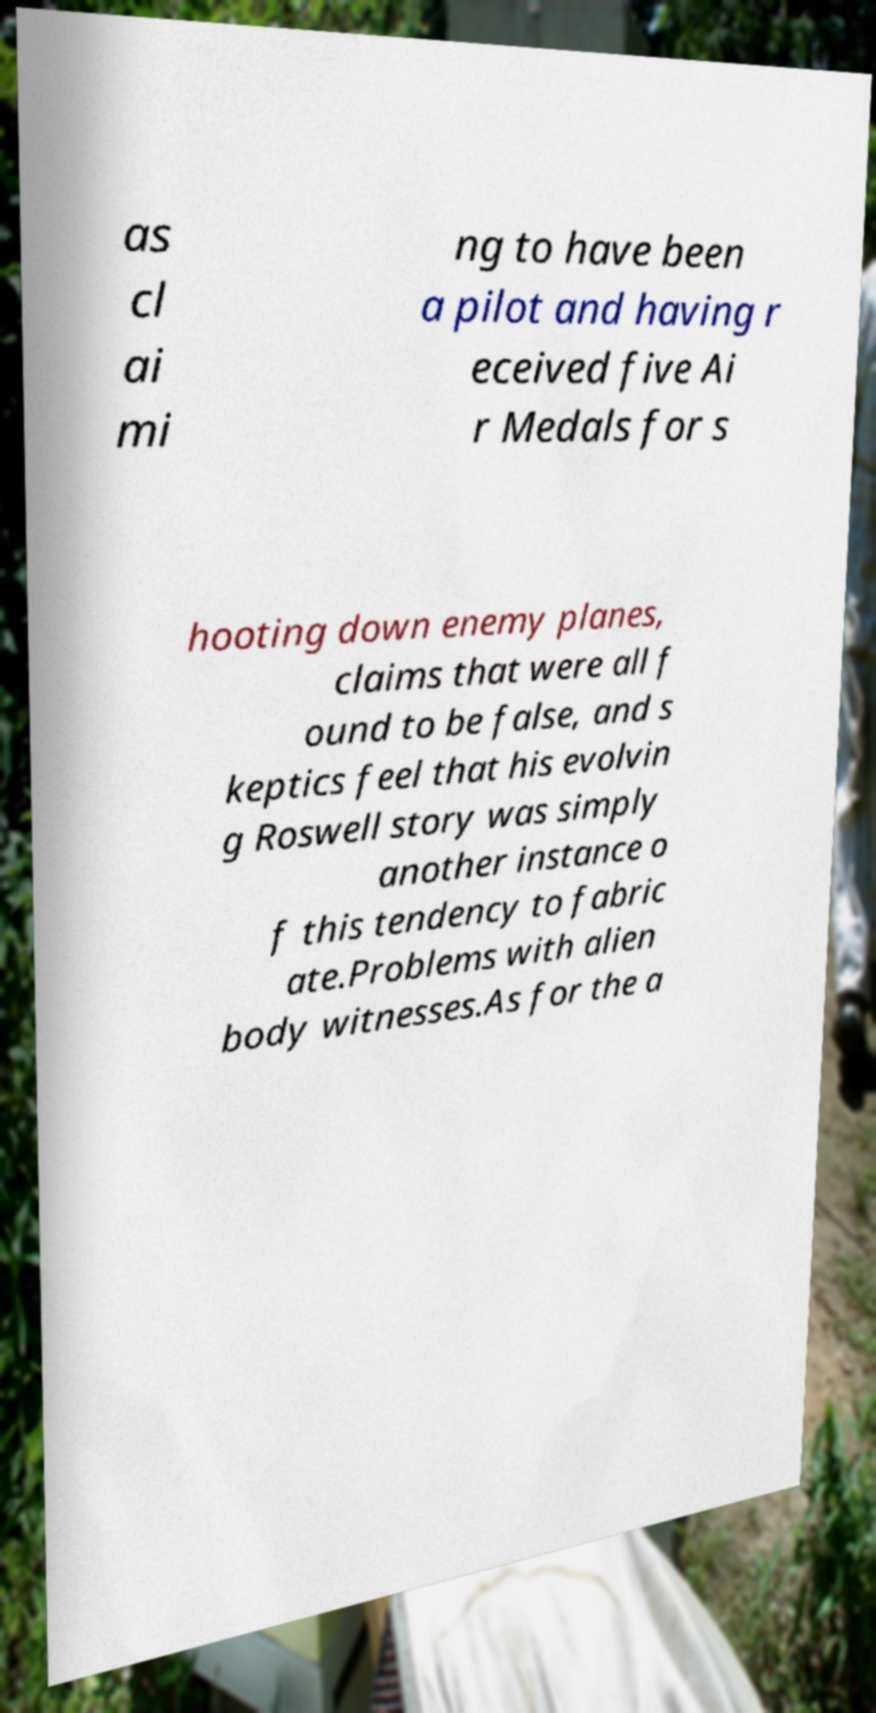Could you extract and type out the text from this image? as cl ai mi ng to have been a pilot and having r eceived five Ai r Medals for s hooting down enemy planes, claims that were all f ound to be false, and s keptics feel that his evolvin g Roswell story was simply another instance o f this tendency to fabric ate.Problems with alien body witnesses.As for the a 